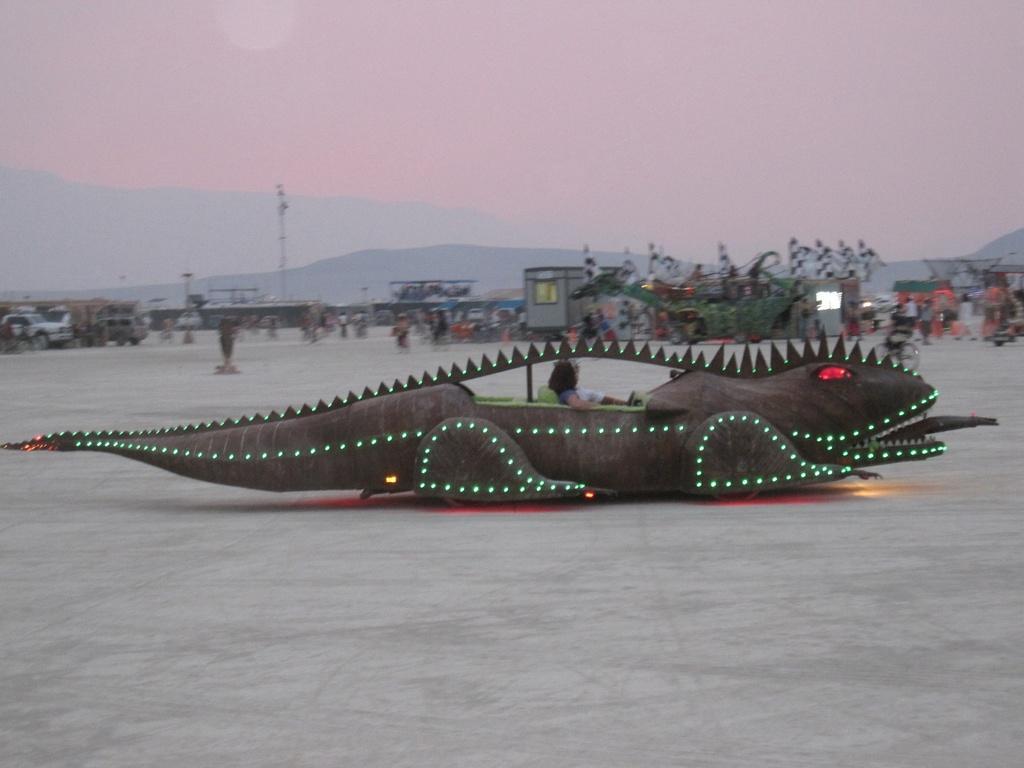Could you give a brief overview of what you see in this image? As we can see in the image there are vehicles, buildings, few people and at the top there is sky. 